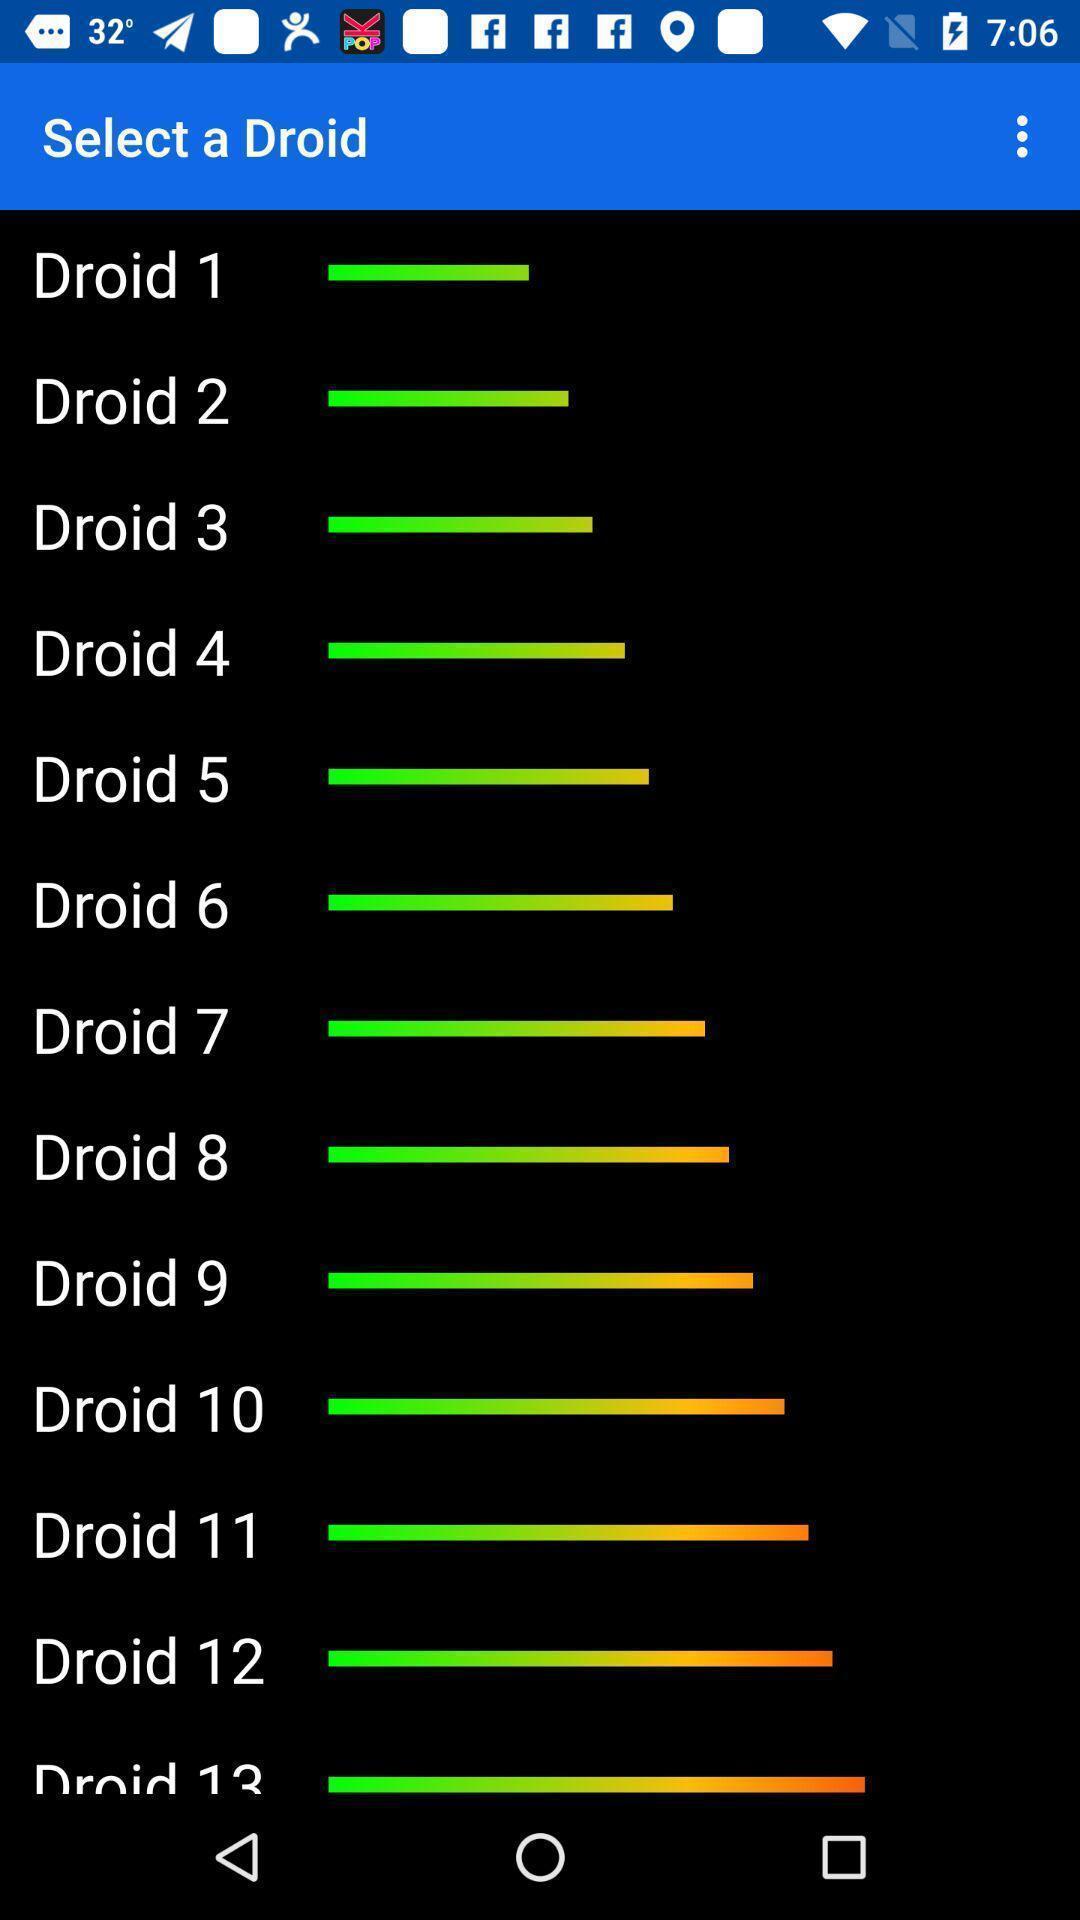Please provide a description for this image. Page displaying the levels of droid. 